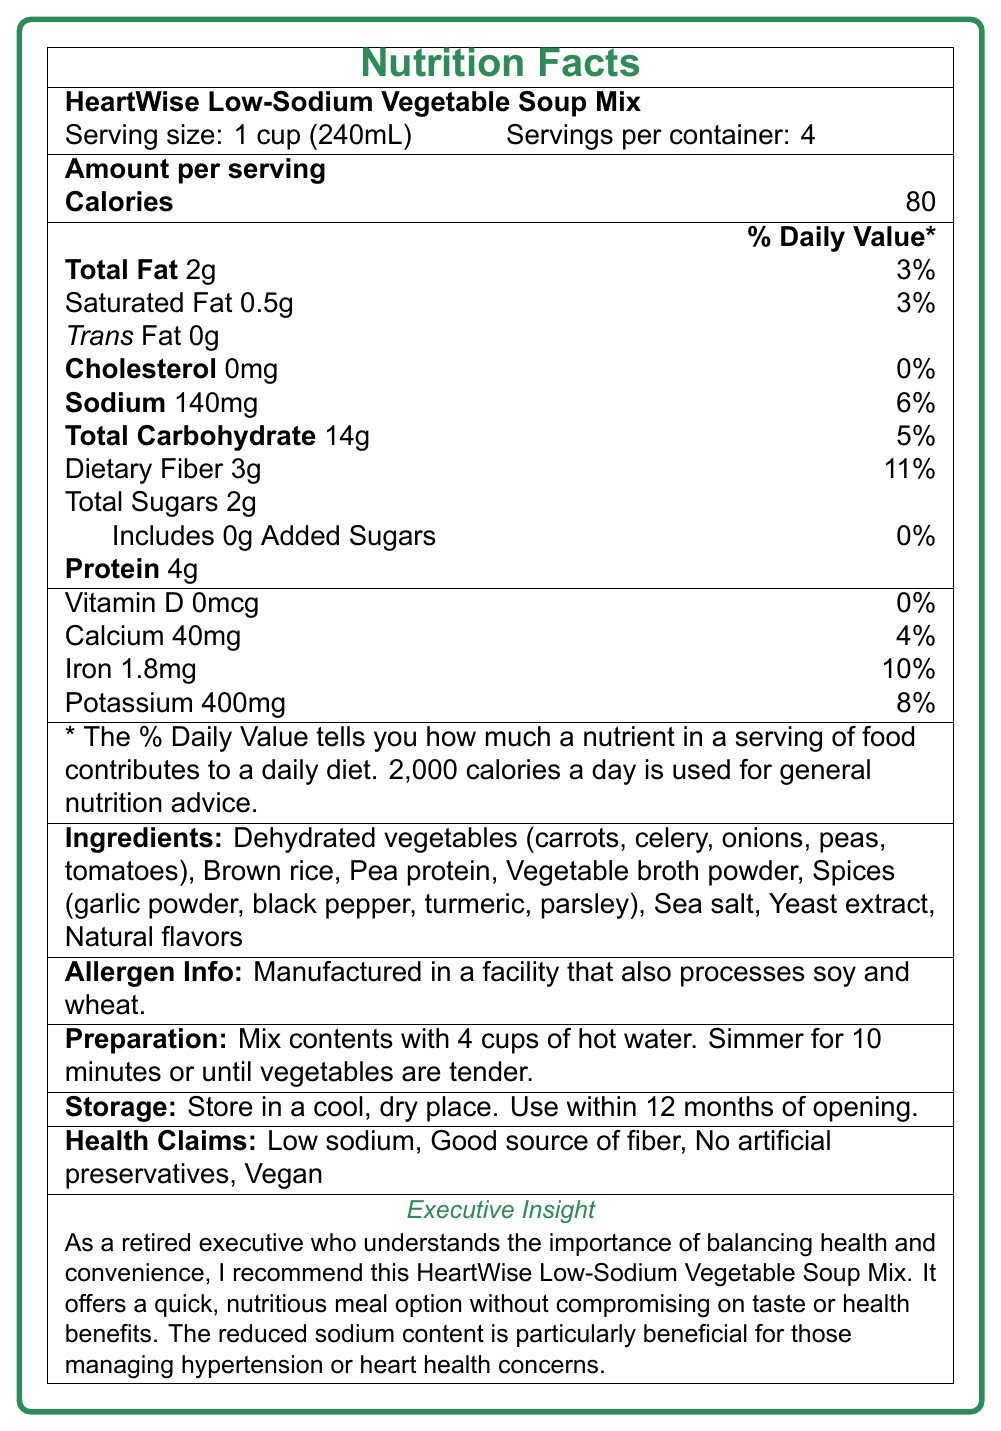what is the serving size? The document explicitly states that the serving size is 1 cup (240mL).
Answer: 1 cup (240mL) how many servings per container? The document mentions that there are 4 servings per container.
Answer: 4 how many calories are in one serving? The document indicates that the amount per serving is 80 calories.
Answer: 80 what is the amount of sodium per serving? According to the document, each serving contains 140mg of sodium.
Answer: 140mg which vitamin is not present in the soup? The document shows that Vitamin D amount is 0mcg per serving.
Answer: Vitamin D what is the percentage of daily value for iron? The document states that iron has a daily value percentage of 10%.
Answer: 10% what is the total gram amount of dietary fiber per serving? The document specifically lists dietary fiber as 3g per serving.
Answer: 3g what are the main ingredients? These ingredients are explicitly listed in the ingredients section of the document.
Answer: Dehydrated vegetables (carrots, celery, onions, peas, tomatoes), Brown rice, Pea protein, Vegetable broth powder, Spices (garlic powder, black pepper, turmeric, parsley), Sea salt, Yeast extract, Natural flavors what are the health claims mentioned? A. High sodium B. Good source of fiber C. Contains artificial preservatives D. Non-vegan The health claims listed are "Low sodium", "Good source of fiber", "No artificial preservatives", and "Vegan".
Answer: B. Good source of fiber which ingredient could potentially be an allergen? A. Carrots B. Sea salt C. Yeast extract D. Wheat The allergen information states the product is manufactured in a facility that also processes soy and wheat.
Answer: D. Wheat how should the soup mix be prepared? The document provides clear preparation instructions.
Answer: Mix contents with 4 cups of hot water. Simmer for 10 minutes or until vegetables are tender. what storage instructions are given? The document specifies the storage instructions clearly.
Answer: Store in a cool, dry place. Use within 12 months of opening. is this soup mix vegan? The health claims section explicitly states that the soup mix is vegan.
Answer: Yes is this soup mix a good option for people managing hypertension? The executive insight mentions that the reduced sodium content is beneficial for those managing hypertension.
Answer: Yes how much protein does one serving contain? The document lists the protein amount per serving as 4g.
Answer: 4g can the exact manufacturing date be determined from this document? The document does not provide information about the manufacturing date.
Answer: Cannot be determined summarize the main idea of the document. The document provides detailed nutritional information, ingredients, preparation instructions, and other relevant information for the HeartWise Low-Sodium Vegetable Soup Mix, emphasizing its health benefits and convenience.
Answer: The document describes the nutrition facts, ingredients, preparation, storage instructions, and health claims of HeartWise Low-Sodium Vegetable Soup Mix. It highlights its low sodium content, making it a good option for health-conscious adults, particularly those managing heart health concerns. 